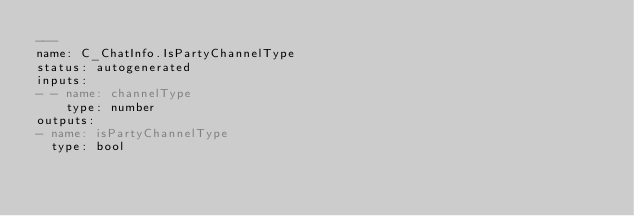<code> <loc_0><loc_0><loc_500><loc_500><_YAML_>---
name: C_ChatInfo.IsPartyChannelType
status: autogenerated
inputs:
- - name: channelType
    type: number
outputs:
- name: isPartyChannelType
  type: bool
</code> 